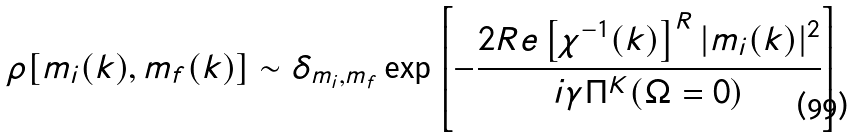Convert formula to latex. <formula><loc_0><loc_0><loc_500><loc_500>\rho [ m _ { i } ( k ) , m _ { f } ( k ) ] \sim \delta _ { m _ { i } , m _ { f } } \exp \left [ - \frac { 2 R e \left [ \chi ^ { - 1 } ( k ) \right ] ^ { R } | m _ { i } ( k ) | ^ { 2 } } { i \gamma \Pi ^ { K } ( \Omega = 0 ) } \right ]</formula> 